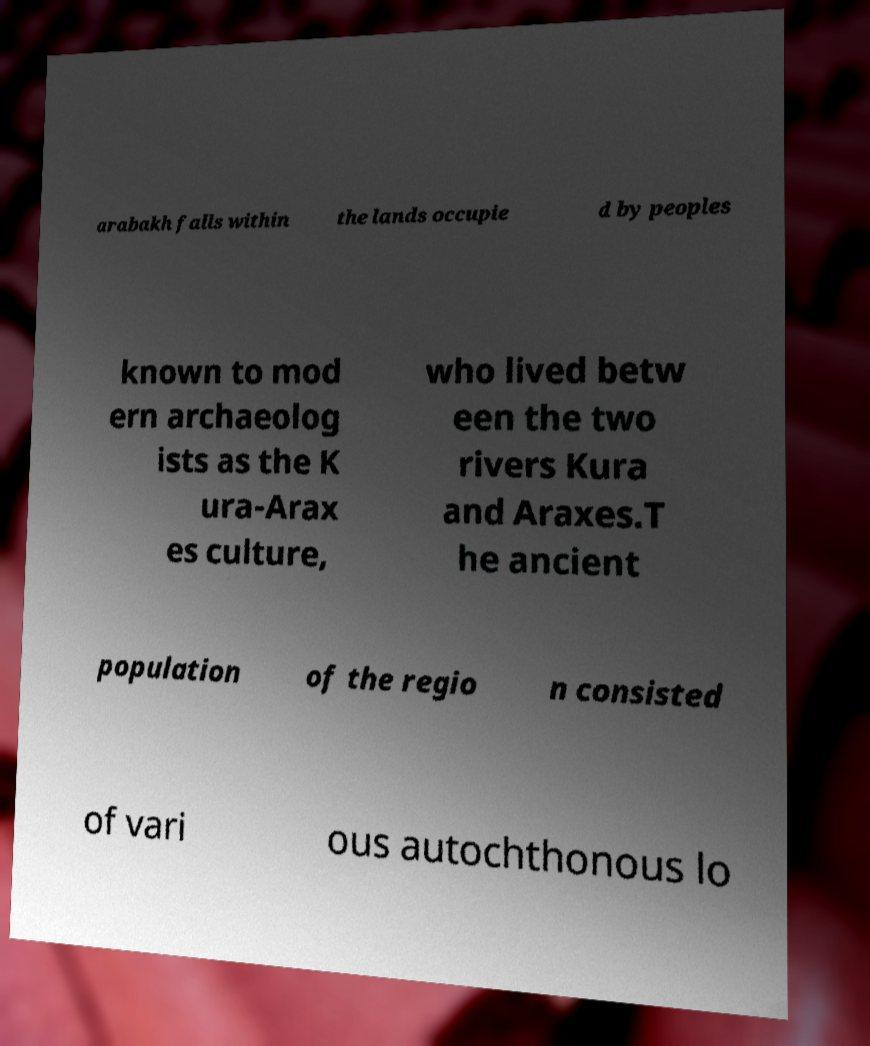Please identify and transcribe the text found in this image. arabakh falls within the lands occupie d by peoples known to mod ern archaeolog ists as the K ura-Arax es culture, who lived betw een the two rivers Kura and Araxes.T he ancient population of the regio n consisted of vari ous autochthonous lo 